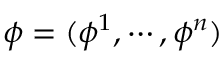Convert formula to latex. <formula><loc_0><loc_0><loc_500><loc_500>\phi = ( \phi ^ { 1 } , \cdots , \phi ^ { n } )</formula> 